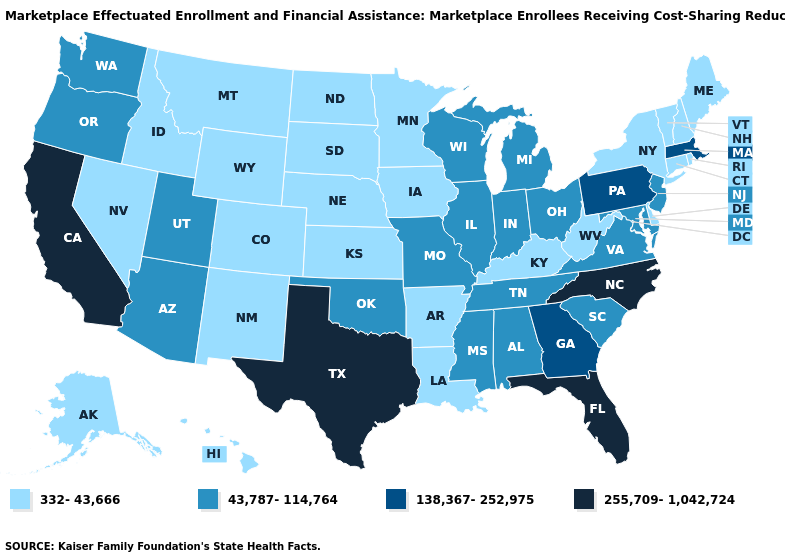Name the states that have a value in the range 138,367-252,975?
Short answer required. Georgia, Massachusetts, Pennsylvania. Does the first symbol in the legend represent the smallest category?
Keep it brief. Yes. What is the highest value in the USA?
Quick response, please. 255,709-1,042,724. Does New Jersey have the highest value in the Northeast?
Answer briefly. No. Which states have the highest value in the USA?
Write a very short answer. California, Florida, North Carolina, Texas. Among the states that border Maine , which have the highest value?
Give a very brief answer. New Hampshire. Does California have the highest value in the West?
Concise answer only. Yes. What is the value of Delaware?
Short answer required. 332-43,666. Is the legend a continuous bar?
Quick response, please. No. What is the lowest value in the Northeast?
Write a very short answer. 332-43,666. What is the highest value in states that border Mississippi?
Keep it brief. 43,787-114,764. What is the value of Idaho?
Quick response, please. 332-43,666. What is the value of Wyoming?
Short answer required. 332-43,666. Name the states that have a value in the range 43,787-114,764?
Answer briefly. Alabama, Arizona, Illinois, Indiana, Maryland, Michigan, Mississippi, Missouri, New Jersey, Ohio, Oklahoma, Oregon, South Carolina, Tennessee, Utah, Virginia, Washington, Wisconsin. Name the states that have a value in the range 43,787-114,764?
Be succinct. Alabama, Arizona, Illinois, Indiana, Maryland, Michigan, Mississippi, Missouri, New Jersey, Ohio, Oklahoma, Oregon, South Carolina, Tennessee, Utah, Virginia, Washington, Wisconsin. 